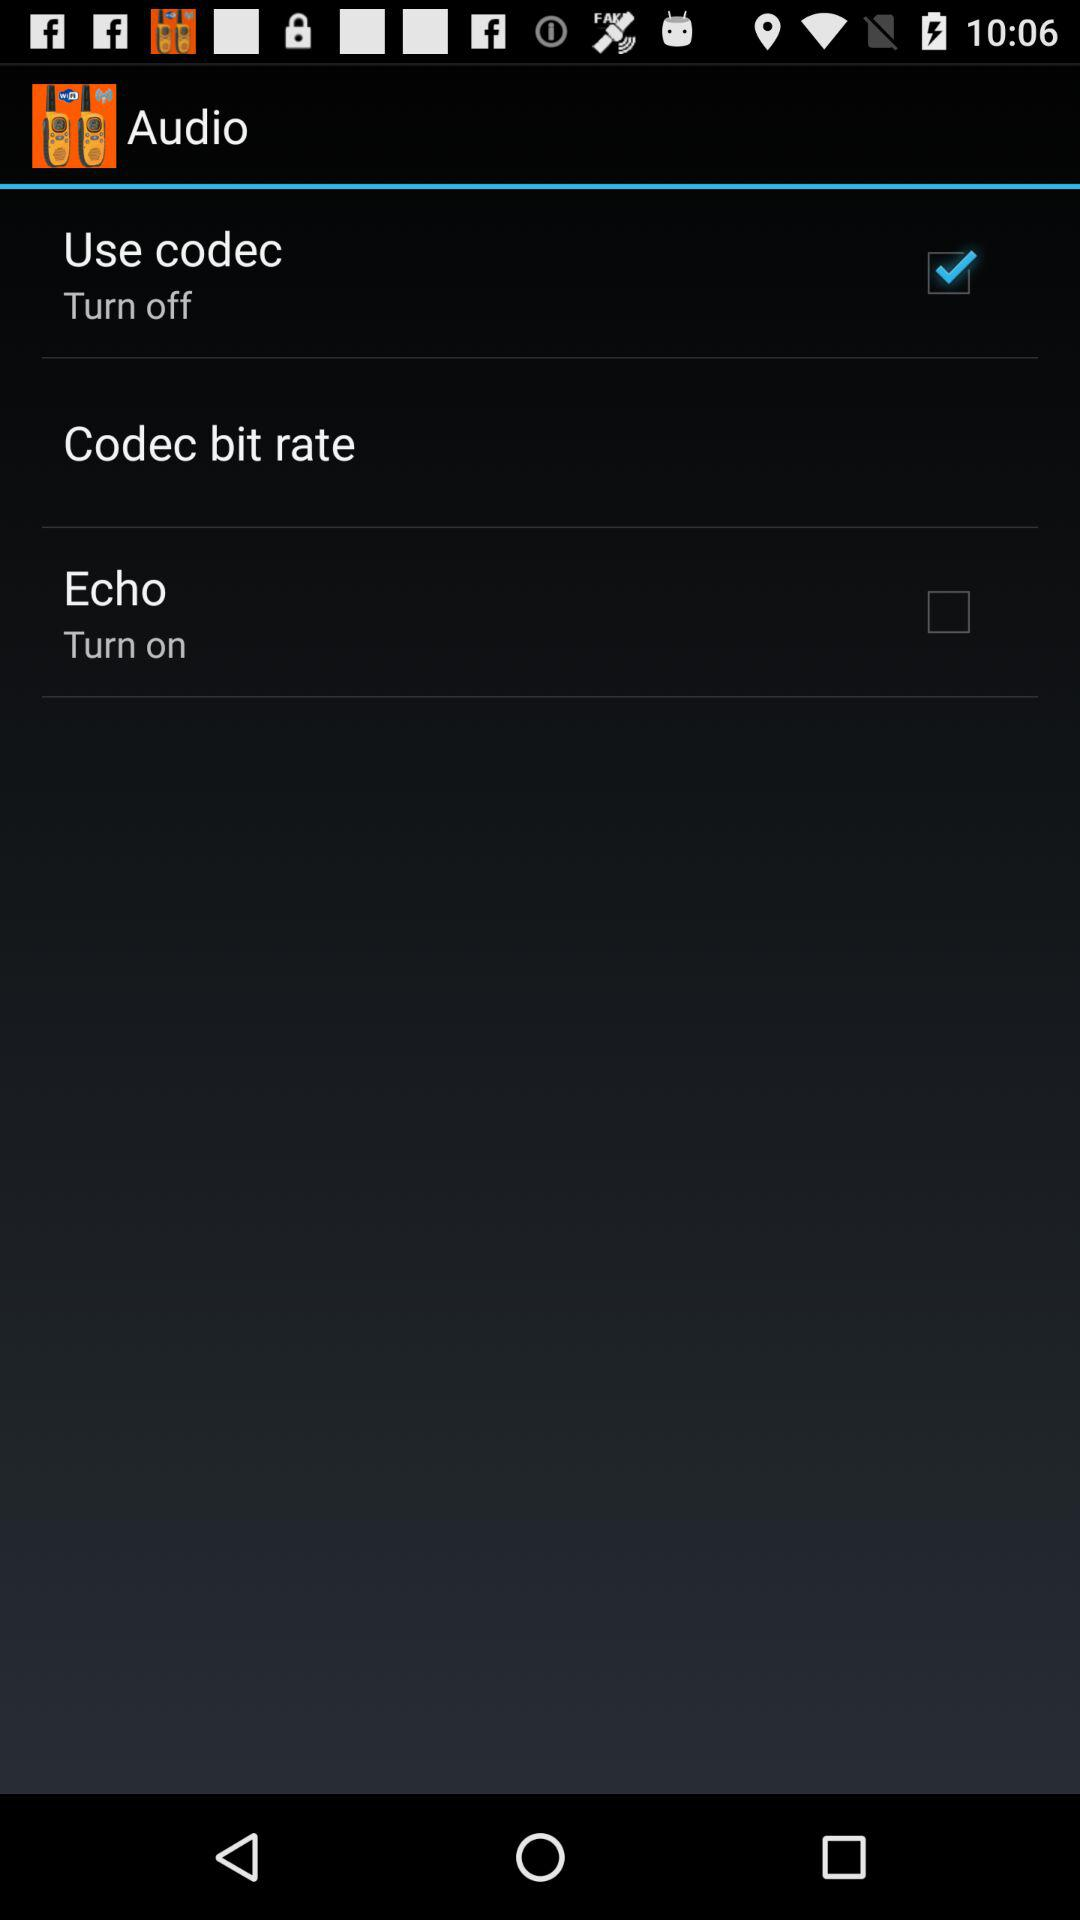What is the selected checkbox? The selected checkbox is "Use codec". 